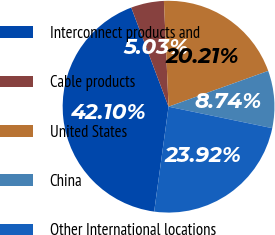Convert chart to OTSL. <chart><loc_0><loc_0><loc_500><loc_500><pie_chart><fcel>Interconnect products and<fcel>Cable products<fcel>United States<fcel>China<fcel>Other International locations<nl><fcel>42.1%<fcel>5.03%<fcel>20.21%<fcel>8.74%<fcel>23.92%<nl></chart> 